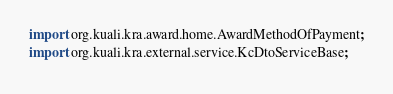<code> <loc_0><loc_0><loc_500><loc_500><_Java_>
import org.kuali.kra.award.home.AwardMethodOfPayment;
import org.kuali.kra.external.service.KcDtoServiceBase;
</code> 